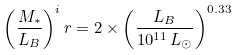<formula> <loc_0><loc_0><loc_500><loc_500>\left ( \frac { M _ { \ast } } { L _ { B } } \right ) ^ { i } r = 2 \times \left ( \frac { L _ { B } } { 1 0 ^ { 1 1 } \, L _ { \odot } } \right ) ^ { 0 . 3 3 }</formula> 